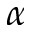<formula> <loc_0><loc_0><loc_500><loc_500>\alpha</formula> 